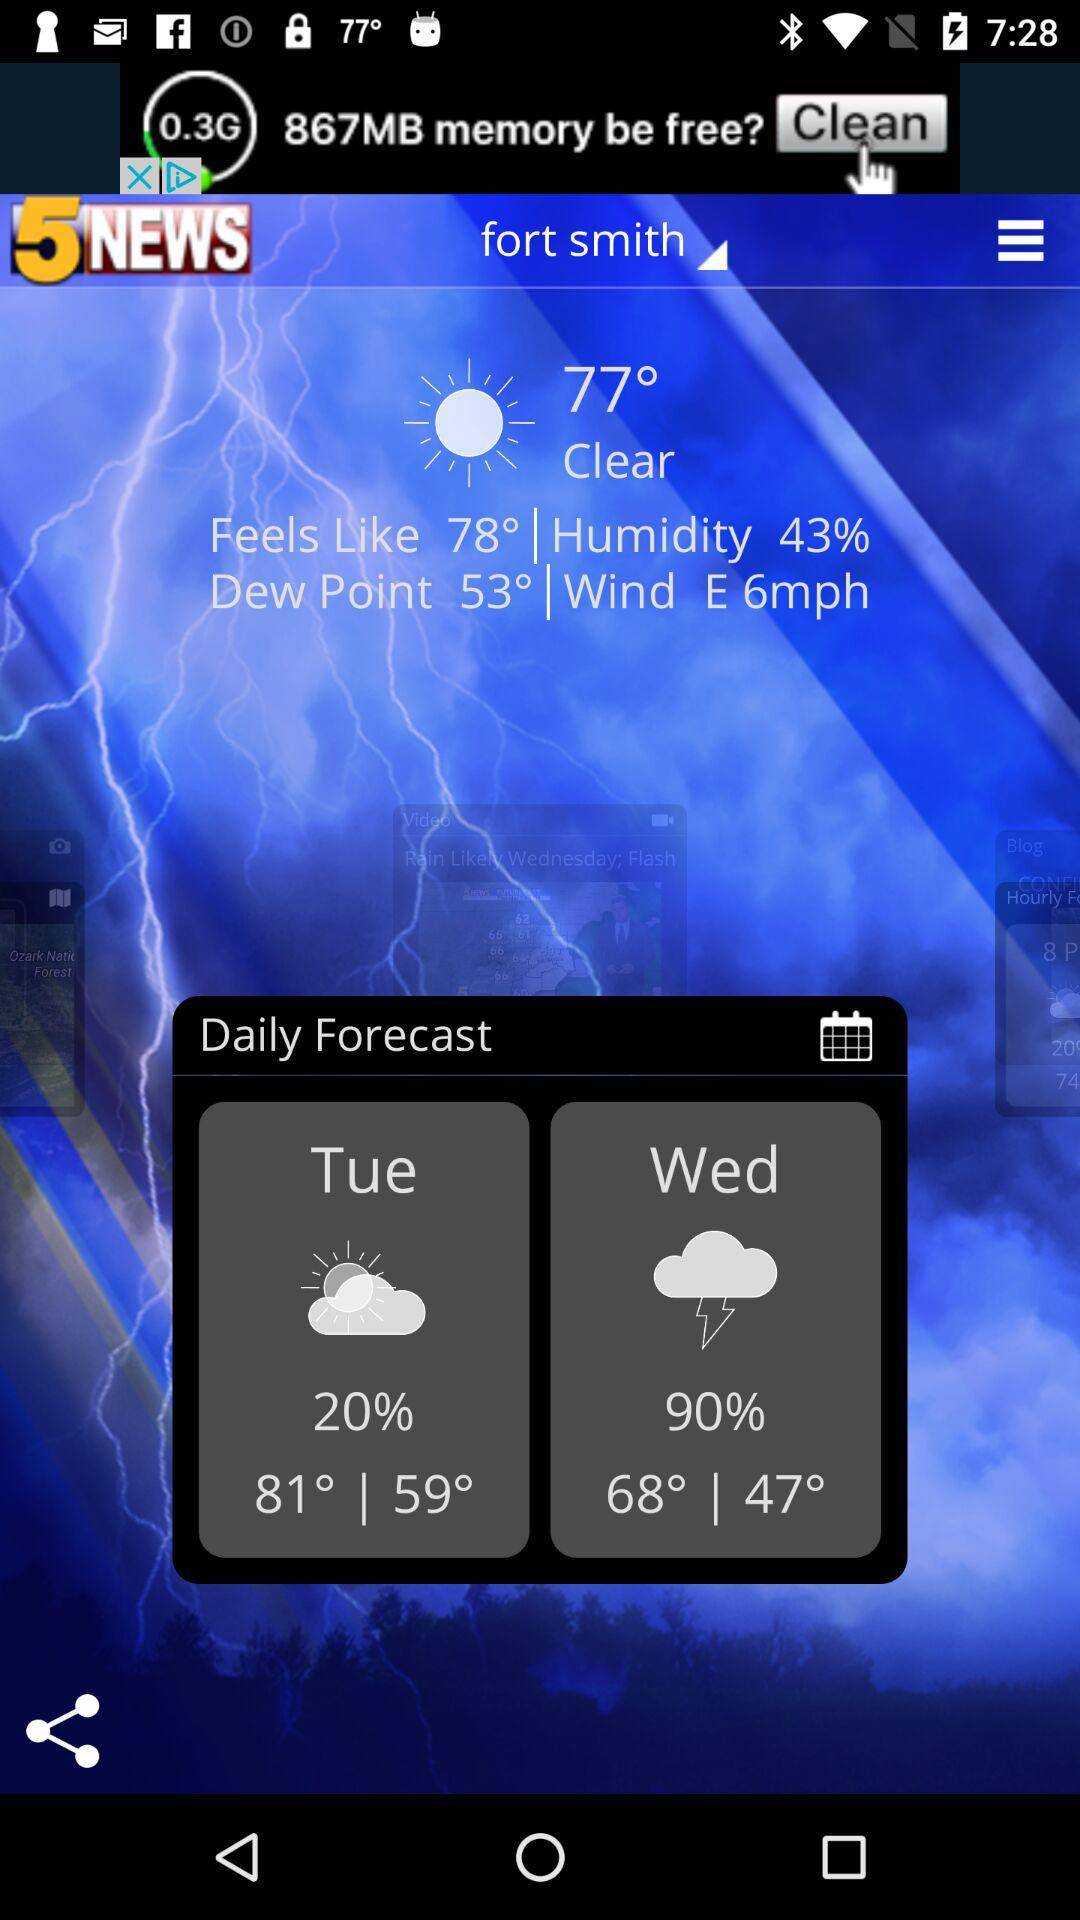How many days are there in the forecast?
Answer the question using a single word or phrase. 2 